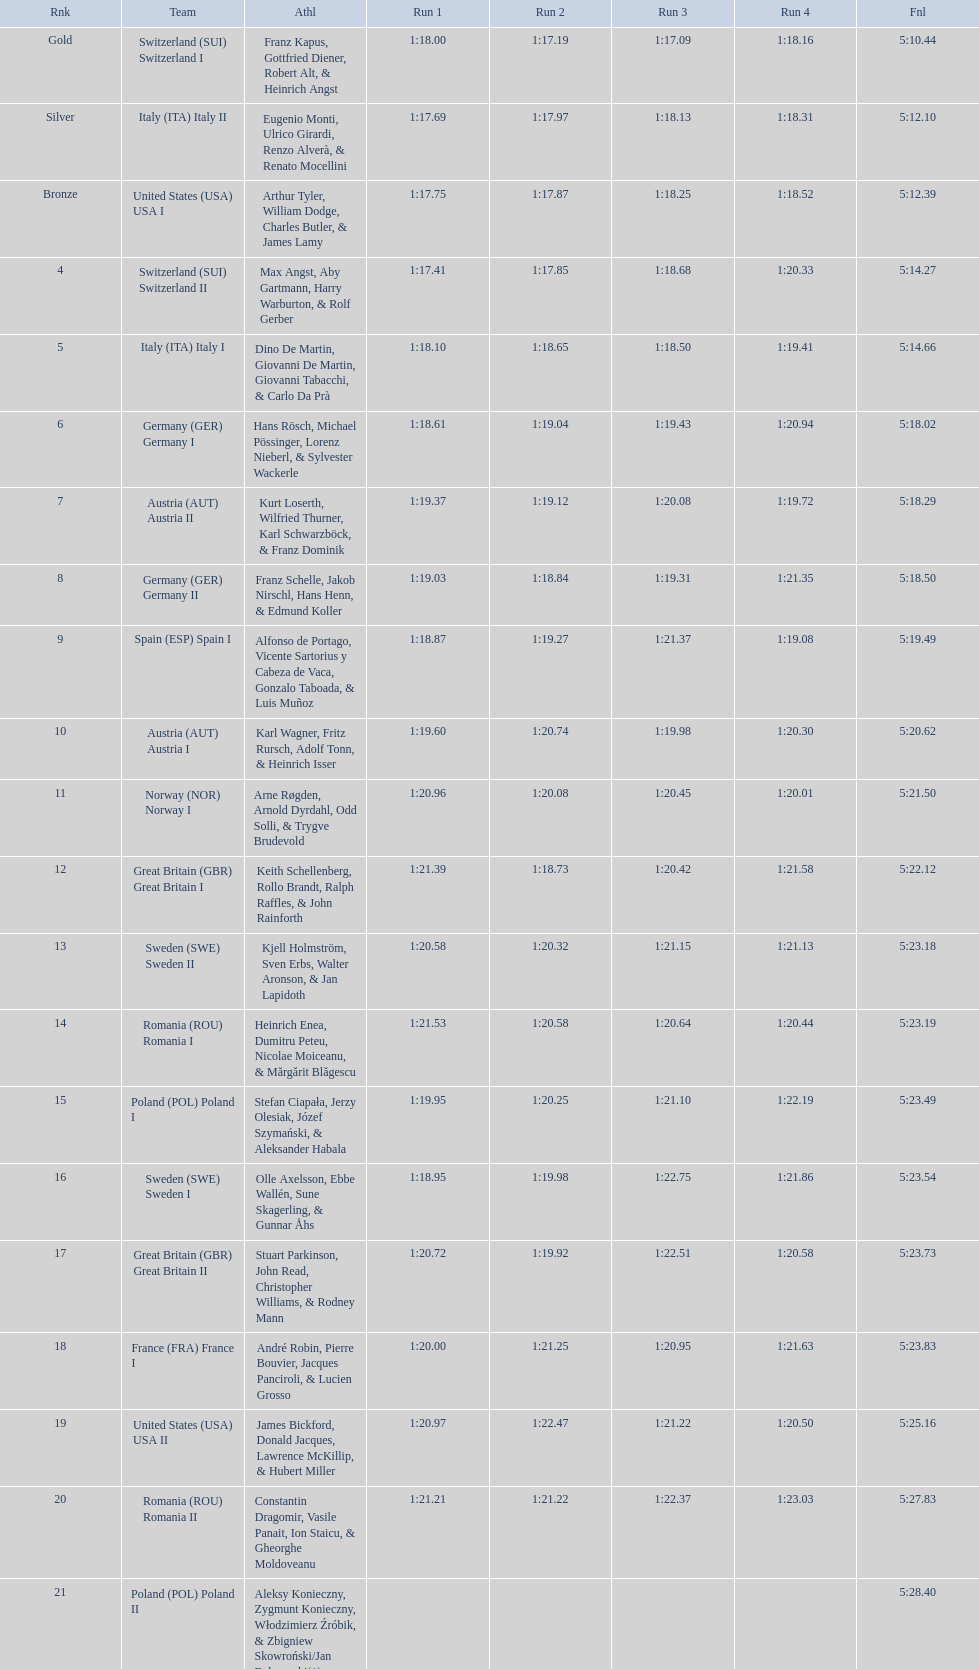Who placed the highest, italy or germany? Italy. 